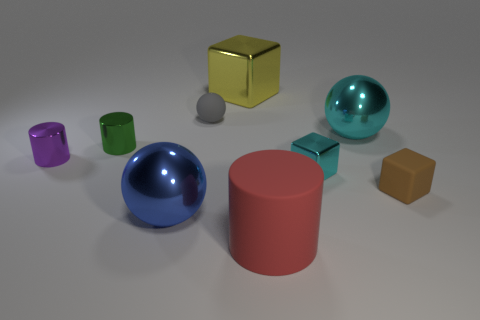How many cubes are either small gray things or tiny purple things?
Offer a very short reply. 0. How many other things are there of the same material as the large blue sphere?
Make the answer very short. 5. What shape is the small rubber thing in front of the gray matte object?
Provide a short and direct response. Cube. What material is the large object that is in front of the big shiny sphere that is left of the large block?
Keep it short and to the point. Rubber. Are there more brown rubber things that are in front of the big red rubber thing than big red matte things?
Your response must be concise. No. What number of other objects are the same color as the tiny ball?
Your response must be concise. 0. There is a green shiny object that is the same size as the brown object; what is its shape?
Your answer should be compact. Cylinder. How many gray spheres are on the left side of the thing in front of the ball that is in front of the purple cylinder?
Your answer should be compact. 1. What number of metal objects are red cylinders or brown cylinders?
Give a very brief answer. 0. There is a small metallic thing that is both in front of the green cylinder and on the left side of the matte cylinder; what is its color?
Provide a succinct answer. Purple. 